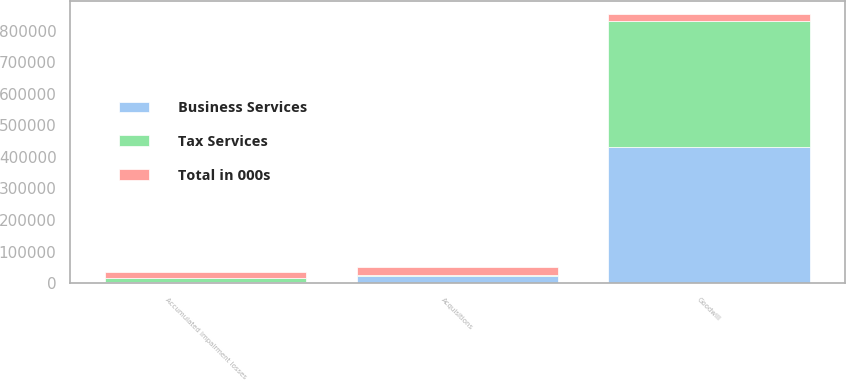<chart> <loc_0><loc_0><loc_500><loc_500><stacked_bar_chart><ecel><fcel>Goodwill<fcel>Acquisitions<fcel>Accumulated impairment losses<nl><fcel>Business Services<fcel>431981<fcel>22692<fcel>2188<nl><fcel>Tax Services<fcel>399333<fcel>3306<fcel>15000<nl><fcel>Total in 000s<fcel>19940<fcel>25998<fcel>17188<nl></chart> 